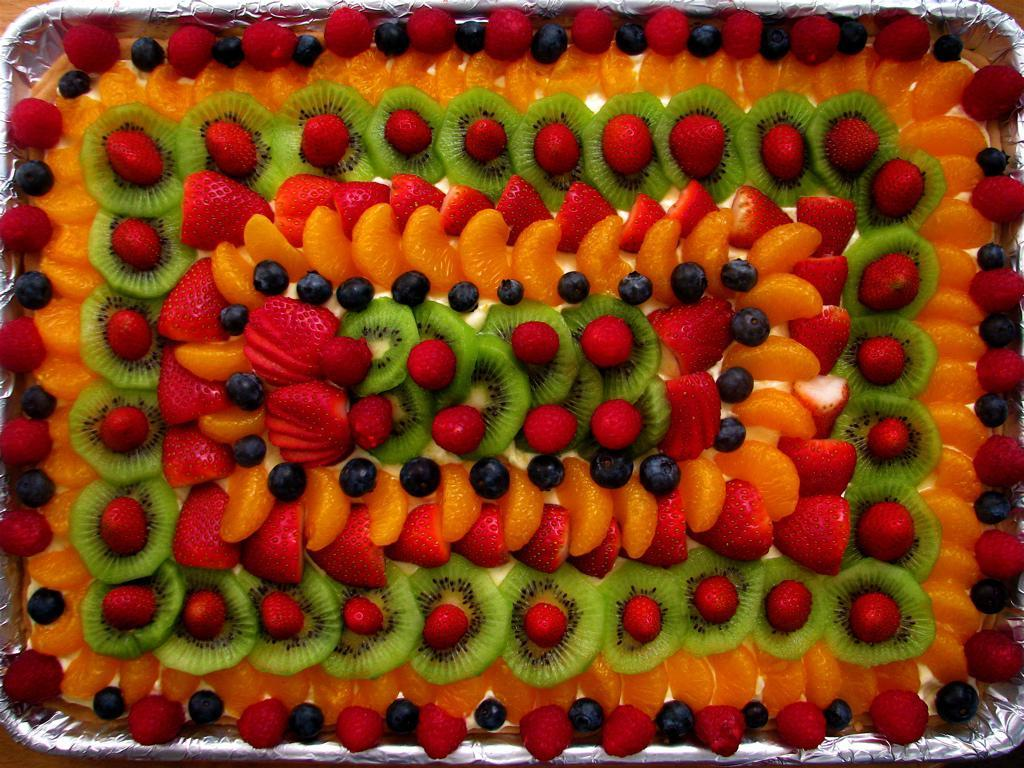What is the main subject of the image? There is a cake in the image. How is the cake decorated? The cake is decorated with fruits. Can you identify any specific fruits on the cake? Strawberries are present on the cake. What type of baseball game is being played in the image? There is no baseball game present in the image; it features a decorated cake with strawberries. How does the wind affect the cake in the image? The image does not depict any wind or its effects on the cake. 